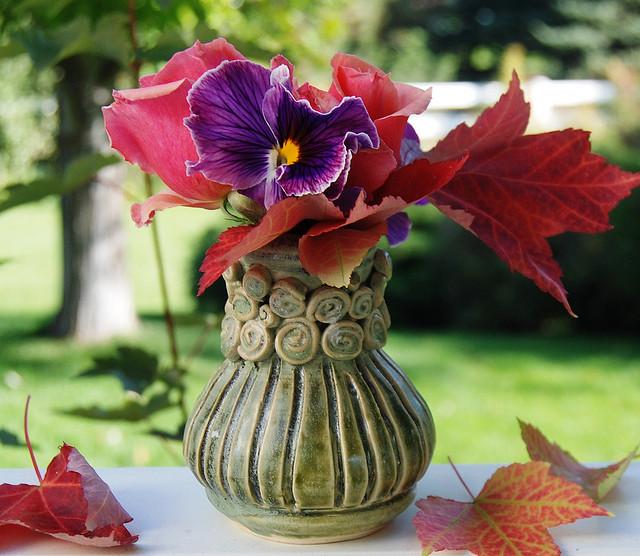What color are the flowers?
Quick response, please. Purple. What color is the vase?
Quick response, please. Green. What is on the table?
Be succinct. Vase. 